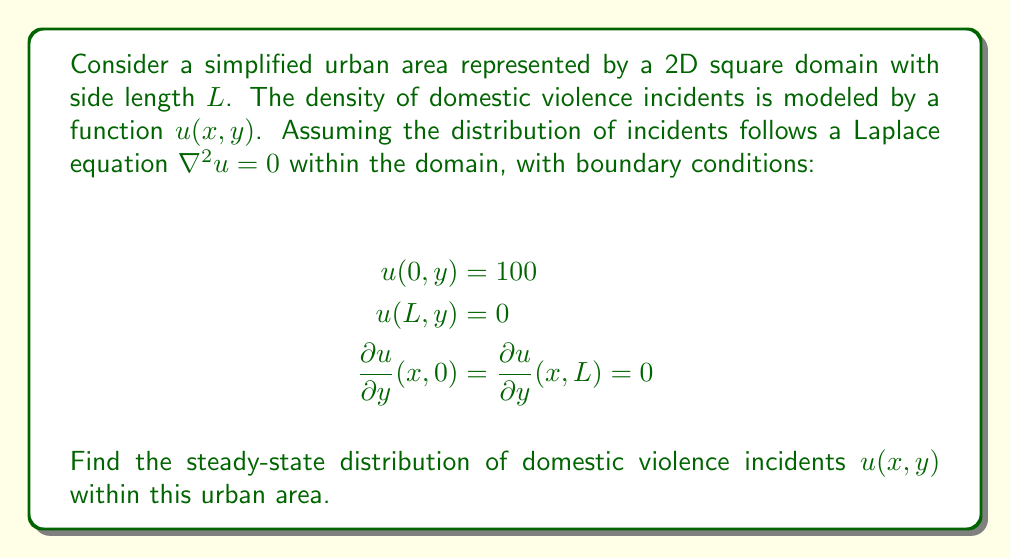Give your solution to this math problem. To solve this problem, we'll use the method of separation of variables:

1) Assume the solution has the form $u(x,y) = X(x)Y(y)$

2) Substituting into the Laplace equation:
   $$\frac{d^2X}{dx^2}Y + X\frac{d^2Y}{dy^2} = 0$$

3) Dividing by XY:
   $$\frac{1}{X}\frac{d^2X}{dx^2} = -\frac{1}{Y}\frac{d^2Y}{dy^2} = -\lambda^2$$

4) This gives us two ODEs:
   $$\frac{d^2X}{dx^2} + \lambda^2X = 0$$
   $$\frac{d^2Y}{dy^2} - \lambda^2Y = 0$$

5) The general solutions are:
   $$X(x) = A\cos(\lambda x) + B\sin(\lambda x)$$
   $$Y(y) = C\cosh(\lambda y) + D\sinh(\lambda y)$$

6) Applying the boundary conditions:
   - $u(0,y) = 100$ implies $X(0) = 100$, so $A = 100$
   - $u(L,y) = 0$ implies $X(L) = 0$, so $100\cos(\lambda L) + B\sin(\lambda L) = 0$
   - $\frac{\partial u}{\partial y}(x,0) = \frac{\partial u}{\partial y}(x,L) = 0$ implies $D = 0$ and $\sinh(\lambda L) = 0$

7) From $\sinh(\lambda L) = 0$, we get $\lambda_n = \frac{n\pi}{L}$ for $n = 0, 1, 2, ...$

8) The solution is a sum of all possible modes:
   $$u(x,y) = \sum_{n=0}^{\infty} (A_n\cos(\frac{n\pi x}{L}) + B_n\sin(\frac{n\pi x}{L}))\cosh(\frac{n\pi y}{L})$$

9) Applying the remaining boundary conditions:
   $$100 = \sum_{n=0}^{\infty} A_n$$
   $$0 = \sum_{n=0}^{\infty} (A_n\cos(n\pi) + B_n\sin(n\pi))$$

10) This implies $A_0 = 100$, $A_n = 0$ for $n > 0$, and $B_n = \frac{200}{n\pi}$ for odd $n$

Therefore, the final solution is:
$$u(x,y) = 100(1 - \frac{x}{L}) + \frac{400}{\pi}\sum_{n=1,3,5,...}^{\infty} \frac{1}{n}\sin(\frac{n\pi x}{L})\cosh(\frac{n\pi y}{L})$$
Answer: $$u(x,y) = 100(1 - \frac{x}{L}) + \frac{400}{\pi}\sum_{n=1,3,5,...}^{\infty} \frac{1}{n}\sin(\frac{n\pi x}{L})\cosh(\frac{n\pi y}{L})$$ 